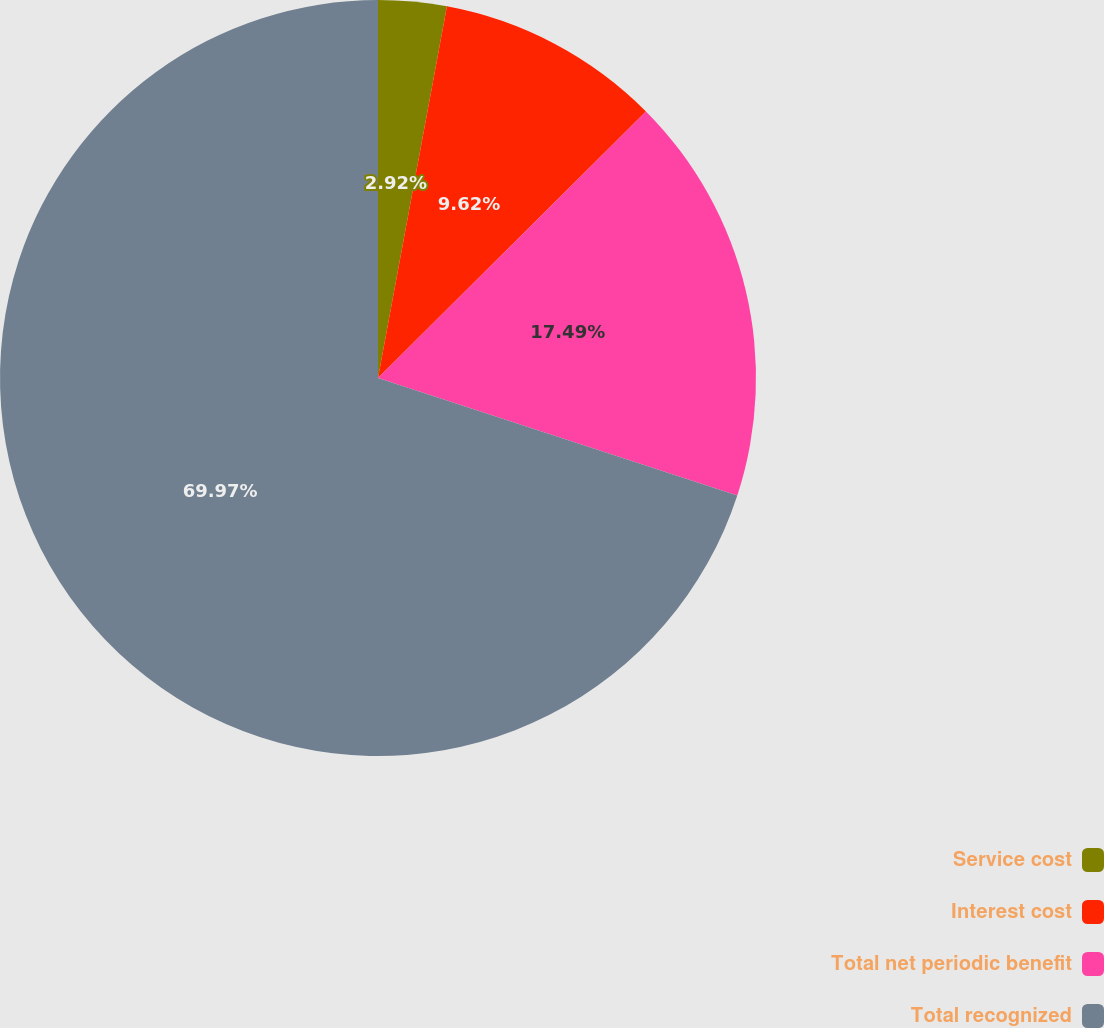Convert chart to OTSL. <chart><loc_0><loc_0><loc_500><loc_500><pie_chart><fcel>Service cost<fcel>Interest cost<fcel>Total net periodic benefit<fcel>Total recognized<nl><fcel>2.92%<fcel>9.62%<fcel>17.49%<fcel>69.97%<nl></chart> 